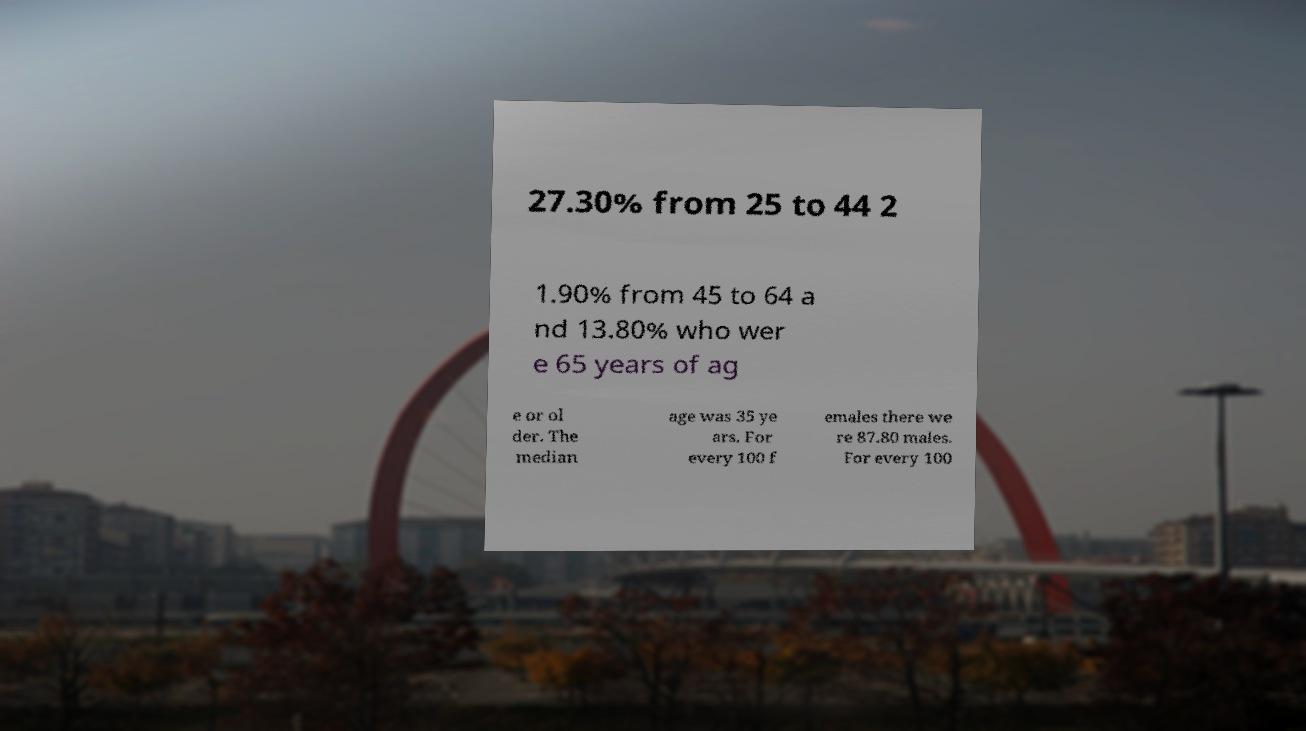There's text embedded in this image that I need extracted. Can you transcribe it verbatim? 27.30% from 25 to 44 2 1.90% from 45 to 64 a nd 13.80% who wer e 65 years of ag e or ol der. The median age was 35 ye ars. For every 100 f emales there we re 87.80 males. For every 100 